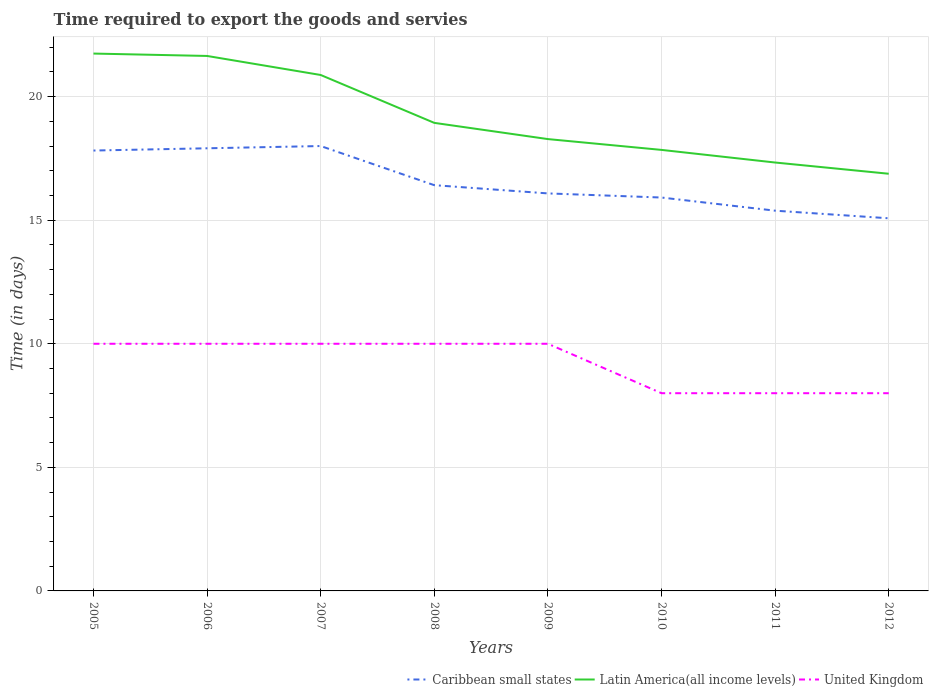How many different coloured lines are there?
Your answer should be very brief. 3. Does the line corresponding to Latin America(all income levels) intersect with the line corresponding to United Kingdom?
Your answer should be compact. No. Is the number of lines equal to the number of legend labels?
Provide a succinct answer. Yes. Across all years, what is the maximum number of days required to export the goods and services in Caribbean small states?
Keep it short and to the point. 15.08. In which year was the number of days required to export the goods and services in Caribbean small states maximum?
Provide a short and direct response. 2012. What is the total number of days required to export the goods and services in Caribbean small states in the graph?
Ensure brevity in your answer.  0.17. What is the difference between the highest and the second highest number of days required to export the goods and services in Latin America(all income levels)?
Provide a succinct answer. 4.86. What is the difference between the highest and the lowest number of days required to export the goods and services in Caribbean small states?
Your response must be concise. 3. How many lines are there?
Offer a very short reply. 3. Does the graph contain any zero values?
Offer a very short reply. No. What is the title of the graph?
Offer a very short reply. Time required to export the goods and servies. What is the label or title of the X-axis?
Provide a short and direct response. Years. What is the label or title of the Y-axis?
Offer a very short reply. Time (in days). What is the Time (in days) in Caribbean small states in 2005?
Offer a very short reply. 17.82. What is the Time (in days) in Latin America(all income levels) in 2005?
Your answer should be compact. 21.74. What is the Time (in days) of Caribbean small states in 2006?
Provide a short and direct response. 17.91. What is the Time (in days) in Latin America(all income levels) in 2006?
Offer a terse response. 21.65. What is the Time (in days) of United Kingdom in 2006?
Offer a terse response. 10. What is the Time (in days) in Latin America(all income levels) in 2007?
Offer a very short reply. 20.88. What is the Time (in days) in Caribbean small states in 2008?
Keep it short and to the point. 16.42. What is the Time (in days) of Latin America(all income levels) in 2008?
Your answer should be compact. 18.94. What is the Time (in days) in Caribbean small states in 2009?
Provide a short and direct response. 16.08. What is the Time (in days) of Latin America(all income levels) in 2009?
Your response must be concise. 18.28. What is the Time (in days) in United Kingdom in 2009?
Ensure brevity in your answer.  10. What is the Time (in days) of Caribbean small states in 2010?
Give a very brief answer. 15.92. What is the Time (in days) of Latin America(all income levels) in 2010?
Ensure brevity in your answer.  17.84. What is the Time (in days) in Caribbean small states in 2011?
Your answer should be very brief. 15.38. What is the Time (in days) in Latin America(all income levels) in 2011?
Offer a terse response. 17.33. What is the Time (in days) in Caribbean small states in 2012?
Make the answer very short. 15.08. What is the Time (in days) of Latin America(all income levels) in 2012?
Provide a short and direct response. 16.88. What is the Time (in days) in United Kingdom in 2012?
Your response must be concise. 8. Across all years, what is the maximum Time (in days) in Latin America(all income levels)?
Keep it short and to the point. 21.74. Across all years, what is the maximum Time (in days) of United Kingdom?
Your answer should be compact. 10. Across all years, what is the minimum Time (in days) of Caribbean small states?
Your response must be concise. 15.08. Across all years, what is the minimum Time (in days) of Latin America(all income levels)?
Offer a very short reply. 16.88. Across all years, what is the minimum Time (in days) of United Kingdom?
Give a very brief answer. 8. What is the total Time (in days) in Caribbean small states in the graph?
Your response must be concise. 132.61. What is the total Time (in days) in Latin America(all income levels) in the graph?
Your response must be concise. 153.54. What is the total Time (in days) of United Kingdom in the graph?
Your answer should be compact. 74. What is the difference between the Time (in days) of Caribbean small states in 2005 and that in 2006?
Offer a terse response. -0.09. What is the difference between the Time (in days) in Latin America(all income levels) in 2005 and that in 2006?
Your answer should be compact. 0.1. What is the difference between the Time (in days) in United Kingdom in 2005 and that in 2006?
Make the answer very short. 0. What is the difference between the Time (in days) of Caribbean small states in 2005 and that in 2007?
Offer a very short reply. -0.18. What is the difference between the Time (in days) of Latin America(all income levels) in 2005 and that in 2007?
Your answer should be very brief. 0.87. What is the difference between the Time (in days) of Caribbean small states in 2005 and that in 2008?
Your response must be concise. 1.4. What is the difference between the Time (in days) in Latin America(all income levels) in 2005 and that in 2008?
Provide a succinct answer. 2.8. What is the difference between the Time (in days) of Caribbean small states in 2005 and that in 2009?
Offer a very short reply. 1.73. What is the difference between the Time (in days) in Latin America(all income levels) in 2005 and that in 2009?
Ensure brevity in your answer.  3.46. What is the difference between the Time (in days) in Caribbean small states in 2005 and that in 2010?
Ensure brevity in your answer.  1.9. What is the difference between the Time (in days) of Latin America(all income levels) in 2005 and that in 2010?
Give a very brief answer. 3.9. What is the difference between the Time (in days) in Caribbean small states in 2005 and that in 2011?
Provide a succinct answer. 2.43. What is the difference between the Time (in days) of Latin America(all income levels) in 2005 and that in 2011?
Provide a short and direct response. 4.41. What is the difference between the Time (in days) of United Kingdom in 2005 and that in 2011?
Your answer should be compact. 2. What is the difference between the Time (in days) of Caribbean small states in 2005 and that in 2012?
Keep it short and to the point. 2.74. What is the difference between the Time (in days) in Latin America(all income levels) in 2005 and that in 2012?
Your response must be concise. 4.86. What is the difference between the Time (in days) of Caribbean small states in 2006 and that in 2007?
Your answer should be compact. -0.09. What is the difference between the Time (in days) in Latin America(all income levels) in 2006 and that in 2007?
Give a very brief answer. 0.77. What is the difference between the Time (in days) in Caribbean small states in 2006 and that in 2008?
Offer a very short reply. 1.49. What is the difference between the Time (in days) in Latin America(all income levels) in 2006 and that in 2008?
Your answer should be very brief. 2.71. What is the difference between the Time (in days) in United Kingdom in 2006 and that in 2008?
Provide a short and direct response. 0. What is the difference between the Time (in days) of Caribbean small states in 2006 and that in 2009?
Keep it short and to the point. 1.83. What is the difference between the Time (in days) of Latin America(all income levels) in 2006 and that in 2009?
Keep it short and to the point. 3.36. What is the difference between the Time (in days) of Caribbean small states in 2006 and that in 2010?
Offer a terse response. 1.99. What is the difference between the Time (in days) in Latin America(all income levels) in 2006 and that in 2010?
Your answer should be very brief. 3.8. What is the difference between the Time (in days) in Caribbean small states in 2006 and that in 2011?
Make the answer very short. 2.52. What is the difference between the Time (in days) of Latin America(all income levels) in 2006 and that in 2011?
Keep it short and to the point. 4.31. What is the difference between the Time (in days) in Caribbean small states in 2006 and that in 2012?
Your response must be concise. 2.83. What is the difference between the Time (in days) of Latin America(all income levels) in 2006 and that in 2012?
Provide a short and direct response. 4.77. What is the difference between the Time (in days) of United Kingdom in 2006 and that in 2012?
Ensure brevity in your answer.  2. What is the difference between the Time (in days) of Caribbean small states in 2007 and that in 2008?
Provide a short and direct response. 1.58. What is the difference between the Time (in days) in Latin America(all income levels) in 2007 and that in 2008?
Offer a terse response. 1.94. What is the difference between the Time (in days) in Caribbean small states in 2007 and that in 2009?
Offer a very short reply. 1.92. What is the difference between the Time (in days) in Latin America(all income levels) in 2007 and that in 2009?
Make the answer very short. 2.59. What is the difference between the Time (in days) of United Kingdom in 2007 and that in 2009?
Provide a succinct answer. 0. What is the difference between the Time (in days) in Caribbean small states in 2007 and that in 2010?
Keep it short and to the point. 2.08. What is the difference between the Time (in days) of Latin America(all income levels) in 2007 and that in 2010?
Ensure brevity in your answer.  3.03. What is the difference between the Time (in days) in United Kingdom in 2007 and that in 2010?
Keep it short and to the point. 2. What is the difference between the Time (in days) of Caribbean small states in 2007 and that in 2011?
Provide a short and direct response. 2.62. What is the difference between the Time (in days) in Latin America(all income levels) in 2007 and that in 2011?
Your answer should be very brief. 3.54. What is the difference between the Time (in days) of United Kingdom in 2007 and that in 2011?
Provide a short and direct response. 2. What is the difference between the Time (in days) of Caribbean small states in 2007 and that in 2012?
Your answer should be very brief. 2.92. What is the difference between the Time (in days) of Latin America(all income levels) in 2007 and that in 2012?
Offer a very short reply. 4. What is the difference between the Time (in days) of United Kingdom in 2007 and that in 2012?
Offer a terse response. 2. What is the difference between the Time (in days) of Latin America(all income levels) in 2008 and that in 2009?
Your response must be concise. 0.66. What is the difference between the Time (in days) in United Kingdom in 2008 and that in 2009?
Give a very brief answer. 0. What is the difference between the Time (in days) in Latin America(all income levels) in 2008 and that in 2010?
Provide a succinct answer. 1.09. What is the difference between the Time (in days) in United Kingdom in 2008 and that in 2010?
Your answer should be compact. 2. What is the difference between the Time (in days) in Caribbean small states in 2008 and that in 2011?
Keep it short and to the point. 1.03. What is the difference between the Time (in days) in Latin America(all income levels) in 2008 and that in 2011?
Provide a succinct answer. 1.6. What is the difference between the Time (in days) in United Kingdom in 2008 and that in 2011?
Provide a short and direct response. 2. What is the difference between the Time (in days) in Caribbean small states in 2008 and that in 2012?
Offer a terse response. 1.34. What is the difference between the Time (in days) of Latin America(all income levels) in 2008 and that in 2012?
Make the answer very short. 2.06. What is the difference between the Time (in days) of Caribbean small states in 2009 and that in 2010?
Your response must be concise. 0.17. What is the difference between the Time (in days) in Latin America(all income levels) in 2009 and that in 2010?
Provide a short and direct response. 0.44. What is the difference between the Time (in days) of Caribbean small states in 2009 and that in 2011?
Give a very brief answer. 0.7. What is the difference between the Time (in days) in Latin America(all income levels) in 2009 and that in 2011?
Offer a terse response. 0.95. What is the difference between the Time (in days) of Caribbean small states in 2009 and that in 2012?
Provide a succinct answer. 1.01. What is the difference between the Time (in days) of Latin America(all income levels) in 2009 and that in 2012?
Offer a very short reply. 1.4. What is the difference between the Time (in days) in Caribbean small states in 2010 and that in 2011?
Ensure brevity in your answer.  0.53. What is the difference between the Time (in days) in Latin America(all income levels) in 2010 and that in 2011?
Offer a terse response. 0.51. What is the difference between the Time (in days) of United Kingdom in 2010 and that in 2011?
Provide a short and direct response. 0. What is the difference between the Time (in days) in Caribbean small states in 2010 and that in 2012?
Provide a succinct answer. 0.84. What is the difference between the Time (in days) in Latin America(all income levels) in 2010 and that in 2012?
Offer a very short reply. 0.96. What is the difference between the Time (in days) of United Kingdom in 2010 and that in 2012?
Keep it short and to the point. 0. What is the difference between the Time (in days) of Caribbean small states in 2011 and that in 2012?
Offer a very short reply. 0.31. What is the difference between the Time (in days) of Latin America(all income levels) in 2011 and that in 2012?
Provide a short and direct response. 0.45. What is the difference between the Time (in days) in Caribbean small states in 2005 and the Time (in days) in Latin America(all income levels) in 2006?
Make the answer very short. -3.83. What is the difference between the Time (in days) in Caribbean small states in 2005 and the Time (in days) in United Kingdom in 2006?
Ensure brevity in your answer.  7.82. What is the difference between the Time (in days) in Latin America(all income levels) in 2005 and the Time (in days) in United Kingdom in 2006?
Your response must be concise. 11.74. What is the difference between the Time (in days) in Caribbean small states in 2005 and the Time (in days) in Latin America(all income levels) in 2007?
Keep it short and to the point. -3.06. What is the difference between the Time (in days) of Caribbean small states in 2005 and the Time (in days) of United Kingdom in 2007?
Provide a succinct answer. 7.82. What is the difference between the Time (in days) in Latin America(all income levels) in 2005 and the Time (in days) in United Kingdom in 2007?
Ensure brevity in your answer.  11.74. What is the difference between the Time (in days) of Caribbean small states in 2005 and the Time (in days) of Latin America(all income levels) in 2008?
Make the answer very short. -1.12. What is the difference between the Time (in days) of Caribbean small states in 2005 and the Time (in days) of United Kingdom in 2008?
Make the answer very short. 7.82. What is the difference between the Time (in days) in Latin America(all income levels) in 2005 and the Time (in days) in United Kingdom in 2008?
Your answer should be compact. 11.74. What is the difference between the Time (in days) in Caribbean small states in 2005 and the Time (in days) in Latin America(all income levels) in 2009?
Your response must be concise. -0.46. What is the difference between the Time (in days) of Caribbean small states in 2005 and the Time (in days) of United Kingdom in 2009?
Offer a very short reply. 7.82. What is the difference between the Time (in days) of Latin America(all income levels) in 2005 and the Time (in days) of United Kingdom in 2009?
Provide a short and direct response. 11.74. What is the difference between the Time (in days) in Caribbean small states in 2005 and the Time (in days) in Latin America(all income levels) in 2010?
Offer a terse response. -0.03. What is the difference between the Time (in days) of Caribbean small states in 2005 and the Time (in days) of United Kingdom in 2010?
Provide a short and direct response. 9.82. What is the difference between the Time (in days) in Latin America(all income levels) in 2005 and the Time (in days) in United Kingdom in 2010?
Offer a very short reply. 13.74. What is the difference between the Time (in days) of Caribbean small states in 2005 and the Time (in days) of Latin America(all income levels) in 2011?
Offer a terse response. 0.48. What is the difference between the Time (in days) of Caribbean small states in 2005 and the Time (in days) of United Kingdom in 2011?
Offer a very short reply. 9.82. What is the difference between the Time (in days) in Latin America(all income levels) in 2005 and the Time (in days) in United Kingdom in 2011?
Your answer should be very brief. 13.74. What is the difference between the Time (in days) of Caribbean small states in 2005 and the Time (in days) of Latin America(all income levels) in 2012?
Your answer should be compact. 0.94. What is the difference between the Time (in days) in Caribbean small states in 2005 and the Time (in days) in United Kingdom in 2012?
Your answer should be very brief. 9.82. What is the difference between the Time (in days) in Latin America(all income levels) in 2005 and the Time (in days) in United Kingdom in 2012?
Keep it short and to the point. 13.74. What is the difference between the Time (in days) in Caribbean small states in 2006 and the Time (in days) in Latin America(all income levels) in 2007?
Give a very brief answer. -2.97. What is the difference between the Time (in days) of Caribbean small states in 2006 and the Time (in days) of United Kingdom in 2007?
Offer a terse response. 7.91. What is the difference between the Time (in days) of Latin America(all income levels) in 2006 and the Time (in days) of United Kingdom in 2007?
Make the answer very short. 11.65. What is the difference between the Time (in days) in Caribbean small states in 2006 and the Time (in days) in Latin America(all income levels) in 2008?
Offer a very short reply. -1.03. What is the difference between the Time (in days) in Caribbean small states in 2006 and the Time (in days) in United Kingdom in 2008?
Offer a very short reply. 7.91. What is the difference between the Time (in days) of Latin America(all income levels) in 2006 and the Time (in days) of United Kingdom in 2008?
Ensure brevity in your answer.  11.65. What is the difference between the Time (in days) in Caribbean small states in 2006 and the Time (in days) in Latin America(all income levels) in 2009?
Provide a succinct answer. -0.37. What is the difference between the Time (in days) of Caribbean small states in 2006 and the Time (in days) of United Kingdom in 2009?
Provide a short and direct response. 7.91. What is the difference between the Time (in days) of Latin America(all income levels) in 2006 and the Time (in days) of United Kingdom in 2009?
Your response must be concise. 11.65. What is the difference between the Time (in days) in Caribbean small states in 2006 and the Time (in days) in Latin America(all income levels) in 2010?
Your answer should be compact. 0.07. What is the difference between the Time (in days) in Caribbean small states in 2006 and the Time (in days) in United Kingdom in 2010?
Your answer should be compact. 9.91. What is the difference between the Time (in days) in Latin America(all income levels) in 2006 and the Time (in days) in United Kingdom in 2010?
Provide a short and direct response. 13.65. What is the difference between the Time (in days) of Caribbean small states in 2006 and the Time (in days) of Latin America(all income levels) in 2011?
Provide a succinct answer. 0.58. What is the difference between the Time (in days) of Caribbean small states in 2006 and the Time (in days) of United Kingdom in 2011?
Your answer should be very brief. 9.91. What is the difference between the Time (in days) of Latin America(all income levels) in 2006 and the Time (in days) of United Kingdom in 2011?
Ensure brevity in your answer.  13.65. What is the difference between the Time (in days) of Caribbean small states in 2006 and the Time (in days) of Latin America(all income levels) in 2012?
Your answer should be compact. 1.03. What is the difference between the Time (in days) of Caribbean small states in 2006 and the Time (in days) of United Kingdom in 2012?
Offer a terse response. 9.91. What is the difference between the Time (in days) in Latin America(all income levels) in 2006 and the Time (in days) in United Kingdom in 2012?
Your answer should be very brief. 13.65. What is the difference between the Time (in days) of Caribbean small states in 2007 and the Time (in days) of Latin America(all income levels) in 2008?
Give a very brief answer. -0.94. What is the difference between the Time (in days) in Caribbean small states in 2007 and the Time (in days) in United Kingdom in 2008?
Your answer should be compact. 8. What is the difference between the Time (in days) in Latin America(all income levels) in 2007 and the Time (in days) in United Kingdom in 2008?
Your answer should be very brief. 10.88. What is the difference between the Time (in days) in Caribbean small states in 2007 and the Time (in days) in Latin America(all income levels) in 2009?
Make the answer very short. -0.28. What is the difference between the Time (in days) in Latin America(all income levels) in 2007 and the Time (in days) in United Kingdom in 2009?
Your response must be concise. 10.88. What is the difference between the Time (in days) in Caribbean small states in 2007 and the Time (in days) in Latin America(all income levels) in 2010?
Provide a succinct answer. 0.16. What is the difference between the Time (in days) in Caribbean small states in 2007 and the Time (in days) in United Kingdom in 2010?
Offer a terse response. 10. What is the difference between the Time (in days) in Latin America(all income levels) in 2007 and the Time (in days) in United Kingdom in 2010?
Keep it short and to the point. 12.88. What is the difference between the Time (in days) of Caribbean small states in 2007 and the Time (in days) of Latin America(all income levels) in 2011?
Provide a succinct answer. 0.67. What is the difference between the Time (in days) in Caribbean small states in 2007 and the Time (in days) in United Kingdom in 2011?
Make the answer very short. 10. What is the difference between the Time (in days) in Latin America(all income levels) in 2007 and the Time (in days) in United Kingdom in 2011?
Offer a very short reply. 12.88. What is the difference between the Time (in days) in Caribbean small states in 2007 and the Time (in days) in Latin America(all income levels) in 2012?
Your answer should be compact. 1.12. What is the difference between the Time (in days) of Caribbean small states in 2007 and the Time (in days) of United Kingdom in 2012?
Provide a short and direct response. 10. What is the difference between the Time (in days) of Latin America(all income levels) in 2007 and the Time (in days) of United Kingdom in 2012?
Offer a very short reply. 12.88. What is the difference between the Time (in days) in Caribbean small states in 2008 and the Time (in days) in Latin America(all income levels) in 2009?
Ensure brevity in your answer.  -1.86. What is the difference between the Time (in days) in Caribbean small states in 2008 and the Time (in days) in United Kingdom in 2009?
Make the answer very short. 6.42. What is the difference between the Time (in days) in Latin America(all income levels) in 2008 and the Time (in days) in United Kingdom in 2009?
Keep it short and to the point. 8.94. What is the difference between the Time (in days) of Caribbean small states in 2008 and the Time (in days) of Latin America(all income levels) in 2010?
Ensure brevity in your answer.  -1.43. What is the difference between the Time (in days) of Caribbean small states in 2008 and the Time (in days) of United Kingdom in 2010?
Keep it short and to the point. 8.42. What is the difference between the Time (in days) in Latin America(all income levels) in 2008 and the Time (in days) in United Kingdom in 2010?
Keep it short and to the point. 10.94. What is the difference between the Time (in days) of Caribbean small states in 2008 and the Time (in days) of Latin America(all income levels) in 2011?
Provide a short and direct response. -0.92. What is the difference between the Time (in days) in Caribbean small states in 2008 and the Time (in days) in United Kingdom in 2011?
Your response must be concise. 8.42. What is the difference between the Time (in days) of Latin America(all income levels) in 2008 and the Time (in days) of United Kingdom in 2011?
Keep it short and to the point. 10.94. What is the difference between the Time (in days) of Caribbean small states in 2008 and the Time (in days) of Latin America(all income levels) in 2012?
Give a very brief answer. -0.46. What is the difference between the Time (in days) in Caribbean small states in 2008 and the Time (in days) in United Kingdom in 2012?
Make the answer very short. 8.42. What is the difference between the Time (in days) of Latin America(all income levels) in 2008 and the Time (in days) of United Kingdom in 2012?
Your answer should be very brief. 10.94. What is the difference between the Time (in days) of Caribbean small states in 2009 and the Time (in days) of Latin America(all income levels) in 2010?
Offer a very short reply. -1.76. What is the difference between the Time (in days) in Caribbean small states in 2009 and the Time (in days) in United Kingdom in 2010?
Your answer should be very brief. 8.08. What is the difference between the Time (in days) in Latin America(all income levels) in 2009 and the Time (in days) in United Kingdom in 2010?
Ensure brevity in your answer.  10.28. What is the difference between the Time (in days) of Caribbean small states in 2009 and the Time (in days) of Latin America(all income levels) in 2011?
Give a very brief answer. -1.25. What is the difference between the Time (in days) of Caribbean small states in 2009 and the Time (in days) of United Kingdom in 2011?
Keep it short and to the point. 8.08. What is the difference between the Time (in days) of Latin America(all income levels) in 2009 and the Time (in days) of United Kingdom in 2011?
Your answer should be compact. 10.28. What is the difference between the Time (in days) of Caribbean small states in 2009 and the Time (in days) of Latin America(all income levels) in 2012?
Your answer should be very brief. -0.8. What is the difference between the Time (in days) of Caribbean small states in 2009 and the Time (in days) of United Kingdom in 2012?
Ensure brevity in your answer.  8.08. What is the difference between the Time (in days) in Latin America(all income levels) in 2009 and the Time (in days) in United Kingdom in 2012?
Your response must be concise. 10.28. What is the difference between the Time (in days) in Caribbean small states in 2010 and the Time (in days) in Latin America(all income levels) in 2011?
Offer a very short reply. -1.42. What is the difference between the Time (in days) of Caribbean small states in 2010 and the Time (in days) of United Kingdom in 2011?
Offer a very short reply. 7.92. What is the difference between the Time (in days) of Latin America(all income levels) in 2010 and the Time (in days) of United Kingdom in 2011?
Your answer should be compact. 9.84. What is the difference between the Time (in days) in Caribbean small states in 2010 and the Time (in days) in Latin America(all income levels) in 2012?
Provide a short and direct response. -0.96. What is the difference between the Time (in days) of Caribbean small states in 2010 and the Time (in days) of United Kingdom in 2012?
Your response must be concise. 7.92. What is the difference between the Time (in days) in Latin America(all income levels) in 2010 and the Time (in days) in United Kingdom in 2012?
Give a very brief answer. 9.84. What is the difference between the Time (in days) of Caribbean small states in 2011 and the Time (in days) of Latin America(all income levels) in 2012?
Keep it short and to the point. -1.49. What is the difference between the Time (in days) in Caribbean small states in 2011 and the Time (in days) in United Kingdom in 2012?
Offer a terse response. 7.38. What is the difference between the Time (in days) in Latin America(all income levels) in 2011 and the Time (in days) in United Kingdom in 2012?
Your response must be concise. 9.33. What is the average Time (in days) in Caribbean small states per year?
Provide a short and direct response. 16.58. What is the average Time (in days) of Latin America(all income levels) per year?
Your answer should be compact. 19.19. What is the average Time (in days) of United Kingdom per year?
Your response must be concise. 9.25. In the year 2005, what is the difference between the Time (in days) in Caribbean small states and Time (in days) in Latin America(all income levels)?
Your answer should be very brief. -3.92. In the year 2005, what is the difference between the Time (in days) of Caribbean small states and Time (in days) of United Kingdom?
Make the answer very short. 7.82. In the year 2005, what is the difference between the Time (in days) of Latin America(all income levels) and Time (in days) of United Kingdom?
Give a very brief answer. 11.74. In the year 2006, what is the difference between the Time (in days) of Caribbean small states and Time (in days) of Latin America(all income levels)?
Your answer should be compact. -3.74. In the year 2006, what is the difference between the Time (in days) in Caribbean small states and Time (in days) in United Kingdom?
Keep it short and to the point. 7.91. In the year 2006, what is the difference between the Time (in days) in Latin America(all income levels) and Time (in days) in United Kingdom?
Make the answer very short. 11.65. In the year 2007, what is the difference between the Time (in days) of Caribbean small states and Time (in days) of Latin America(all income levels)?
Provide a short and direct response. -2.88. In the year 2007, what is the difference between the Time (in days) in Caribbean small states and Time (in days) in United Kingdom?
Your answer should be very brief. 8. In the year 2007, what is the difference between the Time (in days) in Latin America(all income levels) and Time (in days) in United Kingdom?
Ensure brevity in your answer.  10.88. In the year 2008, what is the difference between the Time (in days) in Caribbean small states and Time (in days) in Latin America(all income levels)?
Make the answer very short. -2.52. In the year 2008, what is the difference between the Time (in days) of Caribbean small states and Time (in days) of United Kingdom?
Your answer should be compact. 6.42. In the year 2008, what is the difference between the Time (in days) in Latin America(all income levels) and Time (in days) in United Kingdom?
Your answer should be compact. 8.94. In the year 2009, what is the difference between the Time (in days) in Caribbean small states and Time (in days) in Latin America(all income levels)?
Your answer should be compact. -2.2. In the year 2009, what is the difference between the Time (in days) of Caribbean small states and Time (in days) of United Kingdom?
Your answer should be very brief. 6.08. In the year 2009, what is the difference between the Time (in days) in Latin America(all income levels) and Time (in days) in United Kingdom?
Give a very brief answer. 8.28. In the year 2010, what is the difference between the Time (in days) in Caribbean small states and Time (in days) in Latin America(all income levels)?
Give a very brief answer. -1.93. In the year 2010, what is the difference between the Time (in days) in Caribbean small states and Time (in days) in United Kingdom?
Offer a very short reply. 7.92. In the year 2010, what is the difference between the Time (in days) in Latin America(all income levels) and Time (in days) in United Kingdom?
Offer a terse response. 9.84. In the year 2011, what is the difference between the Time (in days) in Caribbean small states and Time (in days) in Latin America(all income levels)?
Offer a terse response. -1.95. In the year 2011, what is the difference between the Time (in days) in Caribbean small states and Time (in days) in United Kingdom?
Provide a short and direct response. 7.38. In the year 2011, what is the difference between the Time (in days) in Latin America(all income levels) and Time (in days) in United Kingdom?
Your answer should be very brief. 9.33. In the year 2012, what is the difference between the Time (in days) of Caribbean small states and Time (in days) of Latin America(all income levels)?
Make the answer very short. -1.8. In the year 2012, what is the difference between the Time (in days) in Caribbean small states and Time (in days) in United Kingdom?
Your response must be concise. 7.08. In the year 2012, what is the difference between the Time (in days) in Latin America(all income levels) and Time (in days) in United Kingdom?
Offer a terse response. 8.88. What is the ratio of the Time (in days) in Caribbean small states in 2005 to that in 2006?
Your answer should be very brief. 0.99. What is the ratio of the Time (in days) of Latin America(all income levels) in 2005 to that in 2007?
Offer a very short reply. 1.04. What is the ratio of the Time (in days) of Caribbean small states in 2005 to that in 2008?
Ensure brevity in your answer.  1.09. What is the ratio of the Time (in days) of Latin America(all income levels) in 2005 to that in 2008?
Provide a succinct answer. 1.15. What is the ratio of the Time (in days) in United Kingdom in 2005 to that in 2008?
Give a very brief answer. 1. What is the ratio of the Time (in days) in Caribbean small states in 2005 to that in 2009?
Provide a short and direct response. 1.11. What is the ratio of the Time (in days) in Latin America(all income levels) in 2005 to that in 2009?
Your response must be concise. 1.19. What is the ratio of the Time (in days) in Caribbean small states in 2005 to that in 2010?
Your answer should be compact. 1.12. What is the ratio of the Time (in days) in Latin America(all income levels) in 2005 to that in 2010?
Provide a short and direct response. 1.22. What is the ratio of the Time (in days) in United Kingdom in 2005 to that in 2010?
Keep it short and to the point. 1.25. What is the ratio of the Time (in days) of Caribbean small states in 2005 to that in 2011?
Give a very brief answer. 1.16. What is the ratio of the Time (in days) of Latin America(all income levels) in 2005 to that in 2011?
Make the answer very short. 1.25. What is the ratio of the Time (in days) in Caribbean small states in 2005 to that in 2012?
Your response must be concise. 1.18. What is the ratio of the Time (in days) in Latin America(all income levels) in 2005 to that in 2012?
Your answer should be very brief. 1.29. What is the ratio of the Time (in days) in United Kingdom in 2005 to that in 2012?
Your answer should be very brief. 1.25. What is the ratio of the Time (in days) of Caribbean small states in 2006 to that in 2007?
Offer a terse response. 0.99. What is the ratio of the Time (in days) of Latin America(all income levels) in 2006 to that in 2007?
Provide a short and direct response. 1.04. What is the ratio of the Time (in days) of Caribbean small states in 2006 to that in 2008?
Your response must be concise. 1.09. What is the ratio of the Time (in days) of Latin America(all income levels) in 2006 to that in 2008?
Your answer should be very brief. 1.14. What is the ratio of the Time (in days) of Caribbean small states in 2006 to that in 2009?
Offer a very short reply. 1.11. What is the ratio of the Time (in days) in Latin America(all income levels) in 2006 to that in 2009?
Offer a terse response. 1.18. What is the ratio of the Time (in days) of United Kingdom in 2006 to that in 2009?
Provide a succinct answer. 1. What is the ratio of the Time (in days) of Caribbean small states in 2006 to that in 2010?
Offer a very short reply. 1.13. What is the ratio of the Time (in days) in Latin America(all income levels) in 2006 to that in 2010?
Make the answer very short. 1.21. What is the ratio of the Time (in days) of Caribbean small states in 2006 to that in 2011?
Offer a terse response. 1.16. What is the ratio of the Time (in days) of Latin America(all income levels) in 2006 to that in 2011?
Ensure brevity in your answer.  1.25. What is the ratio of the Time (in days) of United Kingdom in 2006 to that in 2011?
Your answer should be very brief. 1.25. What is the ratio of the Time (in days) in Caribbean small states in 2006 to that in 2012?
Provide a succinct answer. 1.19. What is the ratio of the Time (in days) of Latin America(all income levels) in 2006 to that in 2012?
Keep it short and to the point. 1.28. What is the ratio of the Time (in days) of United Kingdom in 2006 to that in 2012?
Your answer should be compact. 1.25. What is the ratio of the Time (in days) in Caribbean small states in 2007 to that in 2008?
Provide a short and direct response. 1.1. What is the ratio of the Time (in days) of Latin America(all income levels) in 2007 to that in 2008?
Give a very brief answer. 1.1. What is the ratio of the Time (in days) in United Kingdom in 2007 to that in 2008?
Provide a short and direct response. 1. What is the ratio of the Time (in days) in Caribbean small states in 2007 to that in 2009?
Your answer should be compact. 1.12. What is the ratio of the Time (in days) in Latin America(all income levels) in 2007 to that in 2009?
Give a very brief answer. 1.14. What is the ratio of the Time (in days) of United Kingdom in 2007 to that in 2009?
Keep it short and to the point. 1. What is the ratio of the Time (in days) of Caribbean small states in 2007 to that in 2010?
Offer a very short reply. 1.13. What is the ratio of the Time (in days) of Latin America(all income levels) in 2007 to that in 2010?
Offer a terse response. 1.17. What is the ratio of the Time (in days) of United Kingdom in 2007 to that in 2010?
Give a very brief answer. 1.25. What is the ratio of the Time (in days) in Caribbean small states in 2007 to that in 2011?
Offer a terse response. 1.17. What is the ratio of the Time (in days) of Latin America(all income levels) in 2007 to that in 2011?
Your answer should be compact. 1.2. What is the ratio of the Time (in days) in Caribbean small states in 2007 to that in 2012?
Keep it short and to the point. 1.19. What is the ratio of the Time (in days) of Latin America(all income levels) in 2007 to that in 2012?
Offer a terse response. 1.24. What is the ratio of the Time (in days) of Caribbean small states in 2008 to that in 2009?
Offer a very short reply. 1.02. What is the ratio of the Time (in days) of Latin America(all income levels) in 2008 to that in 2009?
Provide a short and direct response. 1.04. What is the ratio of the Time (in days) in United Kingdom in 2008 to that in 2009?
Keep it short and to the point. 1. What is the ratio of the Time (in days) in Caribbean small states in 2008 to that in 2010?
Make the answer very short. 1.03. What is the ratio of the Time (in days) of Latin America(all income levels) in 2008 to that in 2010?
Make the answer very short. 1.06. What is the ratio of the Time (in days) in Caribbean small states in 2008 to that in 2011?
Your answer should be compact. 1.07. What is the ratio of the Time (in days) in Latin America(all income levels) in 2008 to that in 2011?
Your answer should be very brief. 1.09. What is the ratio of the Time (in days) in United Kingdom in 2008 to that in 2011?
Ensure brevity in your answer.  1.25. What is the ratio of the Time (in days) of Caribbean small states in 2008 to that in 2012?
Offer a very short reply. 1.09. What is the ratio of the Time (in days) of Latin America(all income levels) in 2008 to that in 2012?
Make the answer very short. 1.12. What is the ratio of the Time (in days) of Caribbean small states in 2009 to that in 2010?
Give a very brief answer. 1.01. What is the ratio of the Time (in days) in Latin America(all income levels) in 2009 to that in 2010?
Give a very brief answer. 1.02. What is the ratio of the Time (in days) in United Kingdom in 2009 to that in 2010?
Give a very brief answer. 1.25. What is the ratio of the Time (in days) of Caribbean small states in 2009 to that in 2011?
Offer a very short reply. 1.05. What is the ratio of the Time (in days) of Latin America(all income levels) in 2009 to that in 2011?
Give a very brief answer. 1.05. What is the ratio of the Time (in days) of Caribbean small states in 2009 to that in 2012?
Keep it short and to the point. 1.07. What is the ratio of the Time (in days) of Latin America(all income levels) in 2009 to that in 2012?
Your answer should be compact. 1.08. What is the ratio of the Time (in days) in United Kingdom in 2009 to that in 2012?
Your response must be concise. 1.25. What is the ratio of the Time (in days) of Caribbean small states in 2010 to that in 2011?
Provide a succinct answer. 1.03. What is the ratio of the Time (in days) in Latin America(all income levels) in 2010 to that in 2011?
Make the answer very short. 1.03. What is the ratio of the Time (in days) of United Kingdom in 2010 to that in 2011?
Make the answer very short. 1. What is the ratio of the Time (in days) in Caribbean small states in 2010 to that in 2012?
Give a very brief answer. 1.06. What is the ratio of the Time (in days) in Latin America(all income levels) in 2010 to that in 2012?
Make the answer very short. 1.06. What is the ratio of the Time (in days) of Caribbean small states in 2011 to that in 2012?
Offer a terse response. 1.02. What is the ratio of the Time (in days) in Latin America(all income levels) in 2011 to that in 2012?
Provide a succinct answer. 1.03. What is the ratio of the Time (in days) in United Kingdom in 2011 to that in 2012?
Keep it short and to the point. 1. What is the difference between the highest and the second highest Time (in days) of Caribbean small states?
Provide a succinct answer. 0.09. What is the difference between the highest and the second highest Time (in days) of Latin America(all income levels)?
Your answer should be very brief. 0.1. What is the difference between the highest and the lowest Time (in days) of Caribbean small states?
Provide a short and direct response. 2.92. What is the difference between the highest and the lowest Time (in days) in Latin America(all income levels)?
Give a very brief answer. 4.86. 